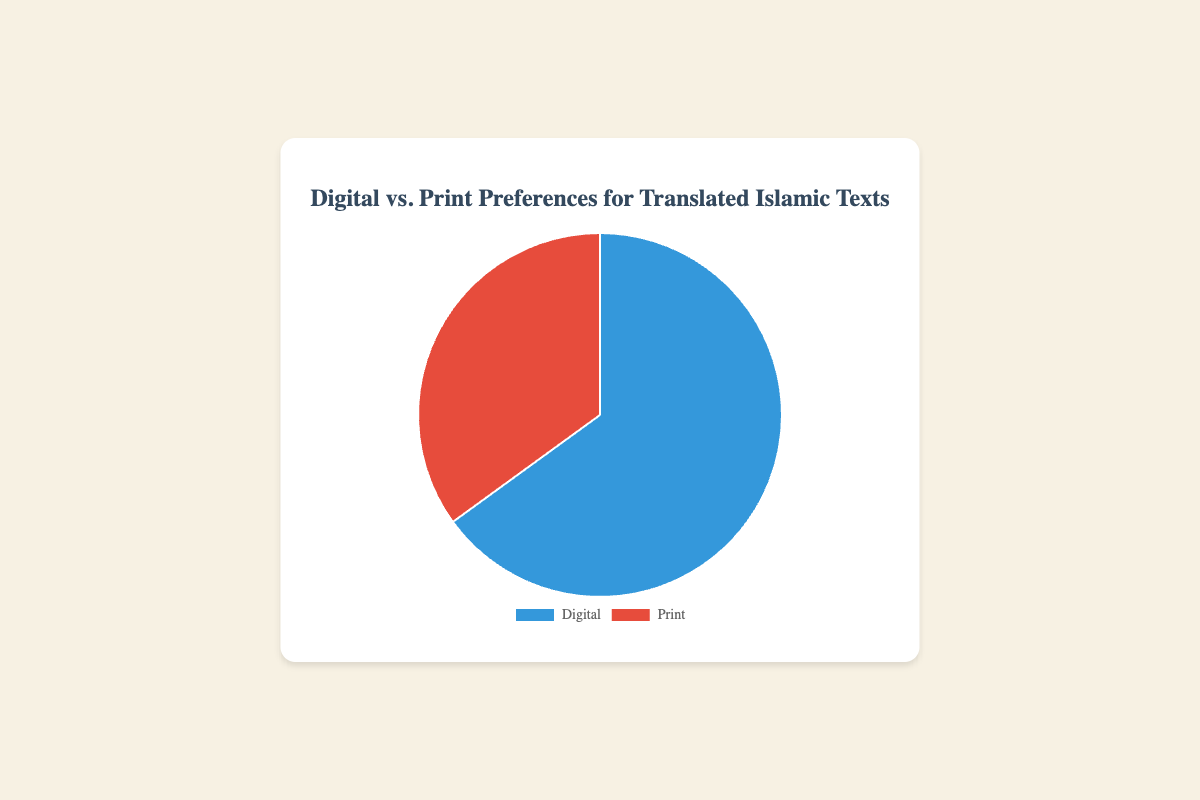What percentage of respondents prefer digital media? The pie chart shows two segments: Digital and Print. The Digital segment represents 65% of the preferences. This is directly indicated in the data point for Digital.
Answer: 65% What percentage of respondents prefer print media? The pie chart shows two sections: Digital and Print. The Print segment represents 35% of the preferences. This is directly indicated in the data point for Print.
Answer: 35% Which media type has a higher preference among respondents? By comparing the two segments in the pie chart, we see that the Digital segment is larger, representing 65%, while the Print segment represents 35%. Therefore, Digital has a higher preference.
Answer: Digital What is the difference in percentage between preferences for digital and print media? The pie chart shows that 65% prefer digital media and 35% prefer print media. The difference is calculated by subtracting the smaller percentage from the larger one: 65% - 35% = 30%.
Answer: 30% What fraction of the respondents prefer digital media? The pie chart shows 65% of respondents prefer digital media. To convert this percentage to a fraction, we get 65/100, which simplifies to 13/20.
Answer: 13/20 If there are 200 respondents, how many prefer print media? The pie chart shows that 35% of respondents prefer print media. To find the number who prefer print media out of 200 respondents, we calculate 35% of 200: (35/100) * 200 = 70.
Answer: 70 What color represents the segment for digital media? The pie chart uses different colors to differentiate between media types. According to the visual, the Digital segment is represented by the color blue.
Answer: Blue If there are 300 respondents, how many prefer digital media? The pie chart indicates 65% of respondents prefer digital media. To find the number who prefer digital media out of 300 respondents, we calculate 65% of 300: (65/100) * 300 = 195.
Answer: 195 By what factor does the preference for digital media exceed the preference for print media? The pie chart shows 65% for digital and 35% for print. To find by what factor the preference for digital exceeds print, divide the percentage preference for digital by the percentage preference for print: 65% / 35% ≈ 1.86.
Answer: 1.86 